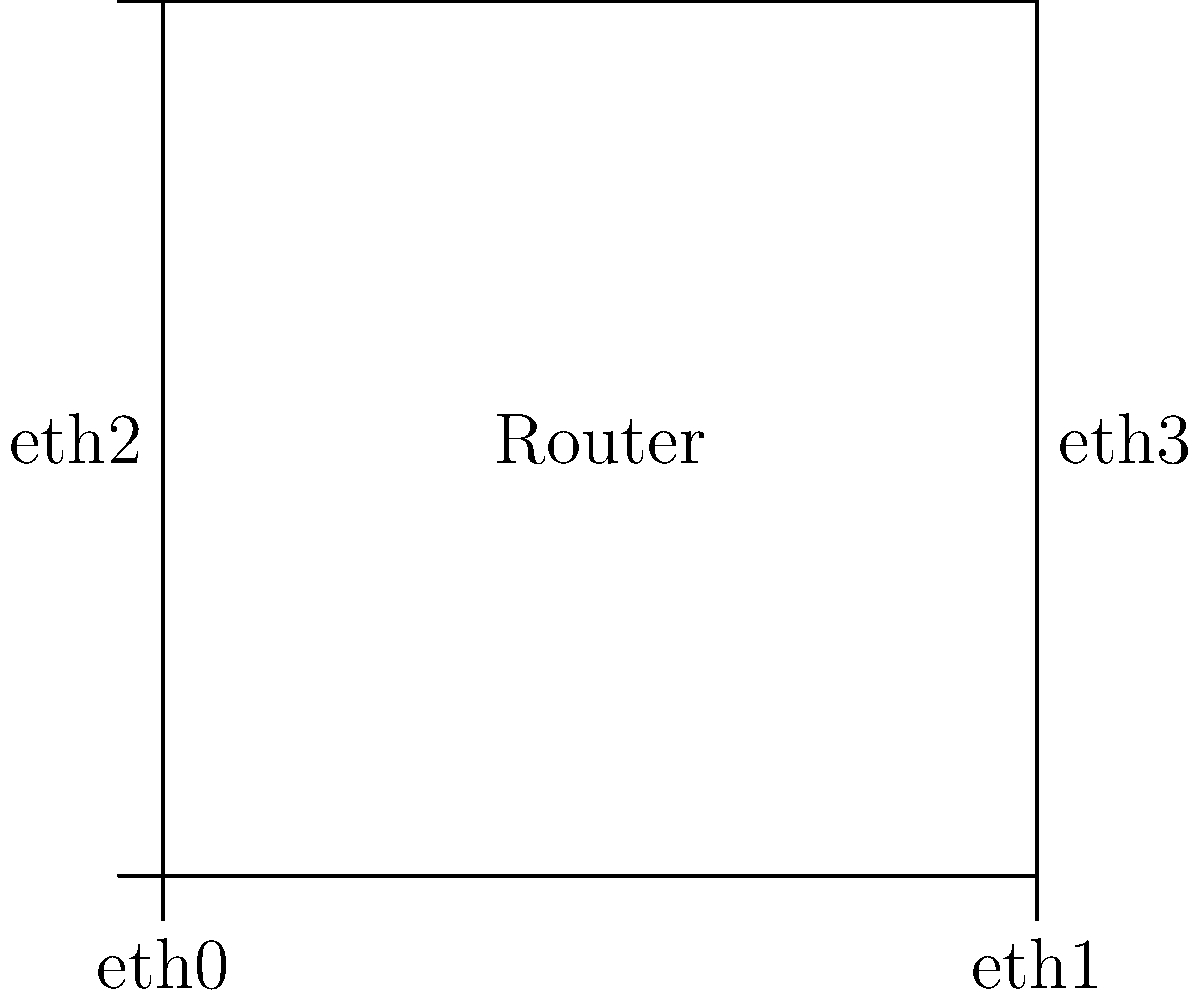Based on the network topology diagram, which configuration file should be edited to set up the network interfaces for this Ubuntu router, and what would be the correct syntax to configure the eth1 interface with an IP address of 192.168.1.1/24? To configure network interfaces in Ubuntu, follow these steps:

1. Identify the configuration file: In Ubuntu, network interfaces are typically configured in the "/etc/netplan" directory. The file is usually named "01-netcfg.yaml" or something similar.

2. Open the file with sudo privileges: Use a text editor like nano or vim to open the file.
   Example: sudo nano /etc/netplan/01-netcfg.yaml

3. Use YAML syntax to configure the interfaces. For eth1:
   - Specify the network renderer (usually networkd for servers)
   - Define the eth1 interface
   - Set the IP address and subnet mask

4. The correct YAML syntax for configuring eth1 would be:

```yaml
network:
  version: 2
  renderer: networkd
  ethernets:
    eth1:
      addresses:
        - 192.168.1.1/24
```

5. Save the file and apply the changes using:
   sudo netplan apply

This configuration sets up eth1 with the IP address 192.168.1.1 and a subnet mask of 255.255.255.0 (/24).
Answer: Edit /etc/netplan/01-netcfg.yaml and add:
network:
  version: 2
  renderer: networkd
  ethernets:
    eth1:
      addresses:
        - 192.168.1.1/24 